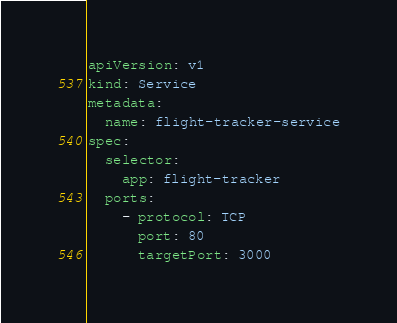Convert code to text. <code><loc_0><loc_0><loc_500><loc_500><_YAML_>apiVersion: v1
kind: Service
metadata:
  name: flight-tracker-service
spec:
  selector:
    app: flight-tracker
  ports:
    - protocol: TCP
      port: 80
      targetPort: 3000</code> 